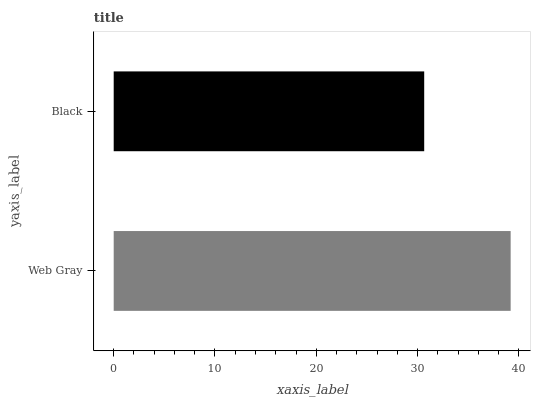Is Black the minimum?
Answer yes or no. Yes. Is Web Gray the maximum?
Answer yes or no. Yes. Is Black the maximum?
Answer yes or no. No. Is Web Gray greater than Black?
Answer yes or no. Yes. Is Black less than Web Gray?
Answer yes or no. Yes. Is Black greater than Web Gray?
Answer yes or no. No. Is Web Gray less than Black?
Answer yes or no. No. Is Web Gray the high median?
Answer yes or no. Yes. Is Black the low median?
Answer yes or no. Yes. Is Black the high median?
Answer yes or no. No. Is Web Gray the low median?
Answer yes or no. No. 